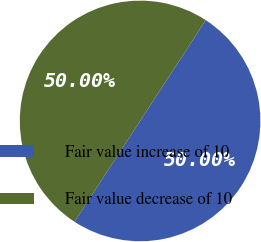Convert chart to OTSL. <chart><loc_0><loc_0><loc_500><loc_500><pie_chart><fcel>Fair value increase of 10<fcel>Fair value decrease of 10<nl><fcel>50.0%<fcel>50.0%<nl></chart> 